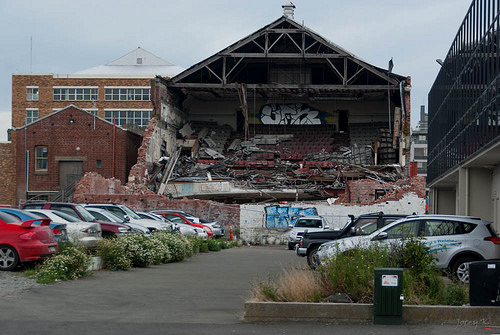<image>
Can you confirm if the car is in front of the car? Yes. The car is positioned in front of the car, appearing closer to the camera viewpoint. 